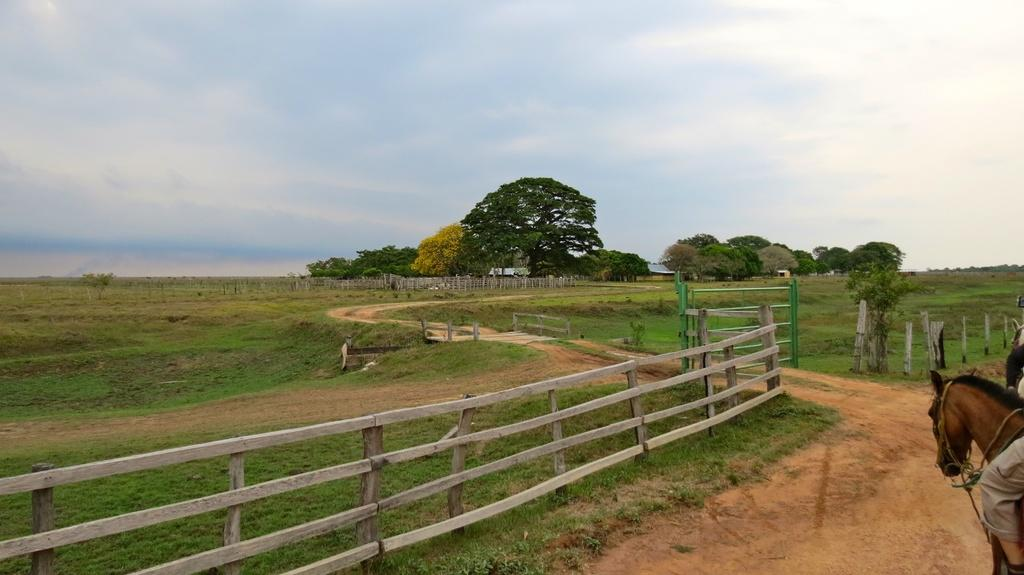What is the main subject of the image? There is a person on a horse in the image. What can be seen in the background of the image? There is fencing and trees in the image. What is visible in the sky in the image? The sky is visible in the image. What color of paint is being used by the cat in the image? There is no cat present in the image, and therefore no paint or painting activity can be observed. 